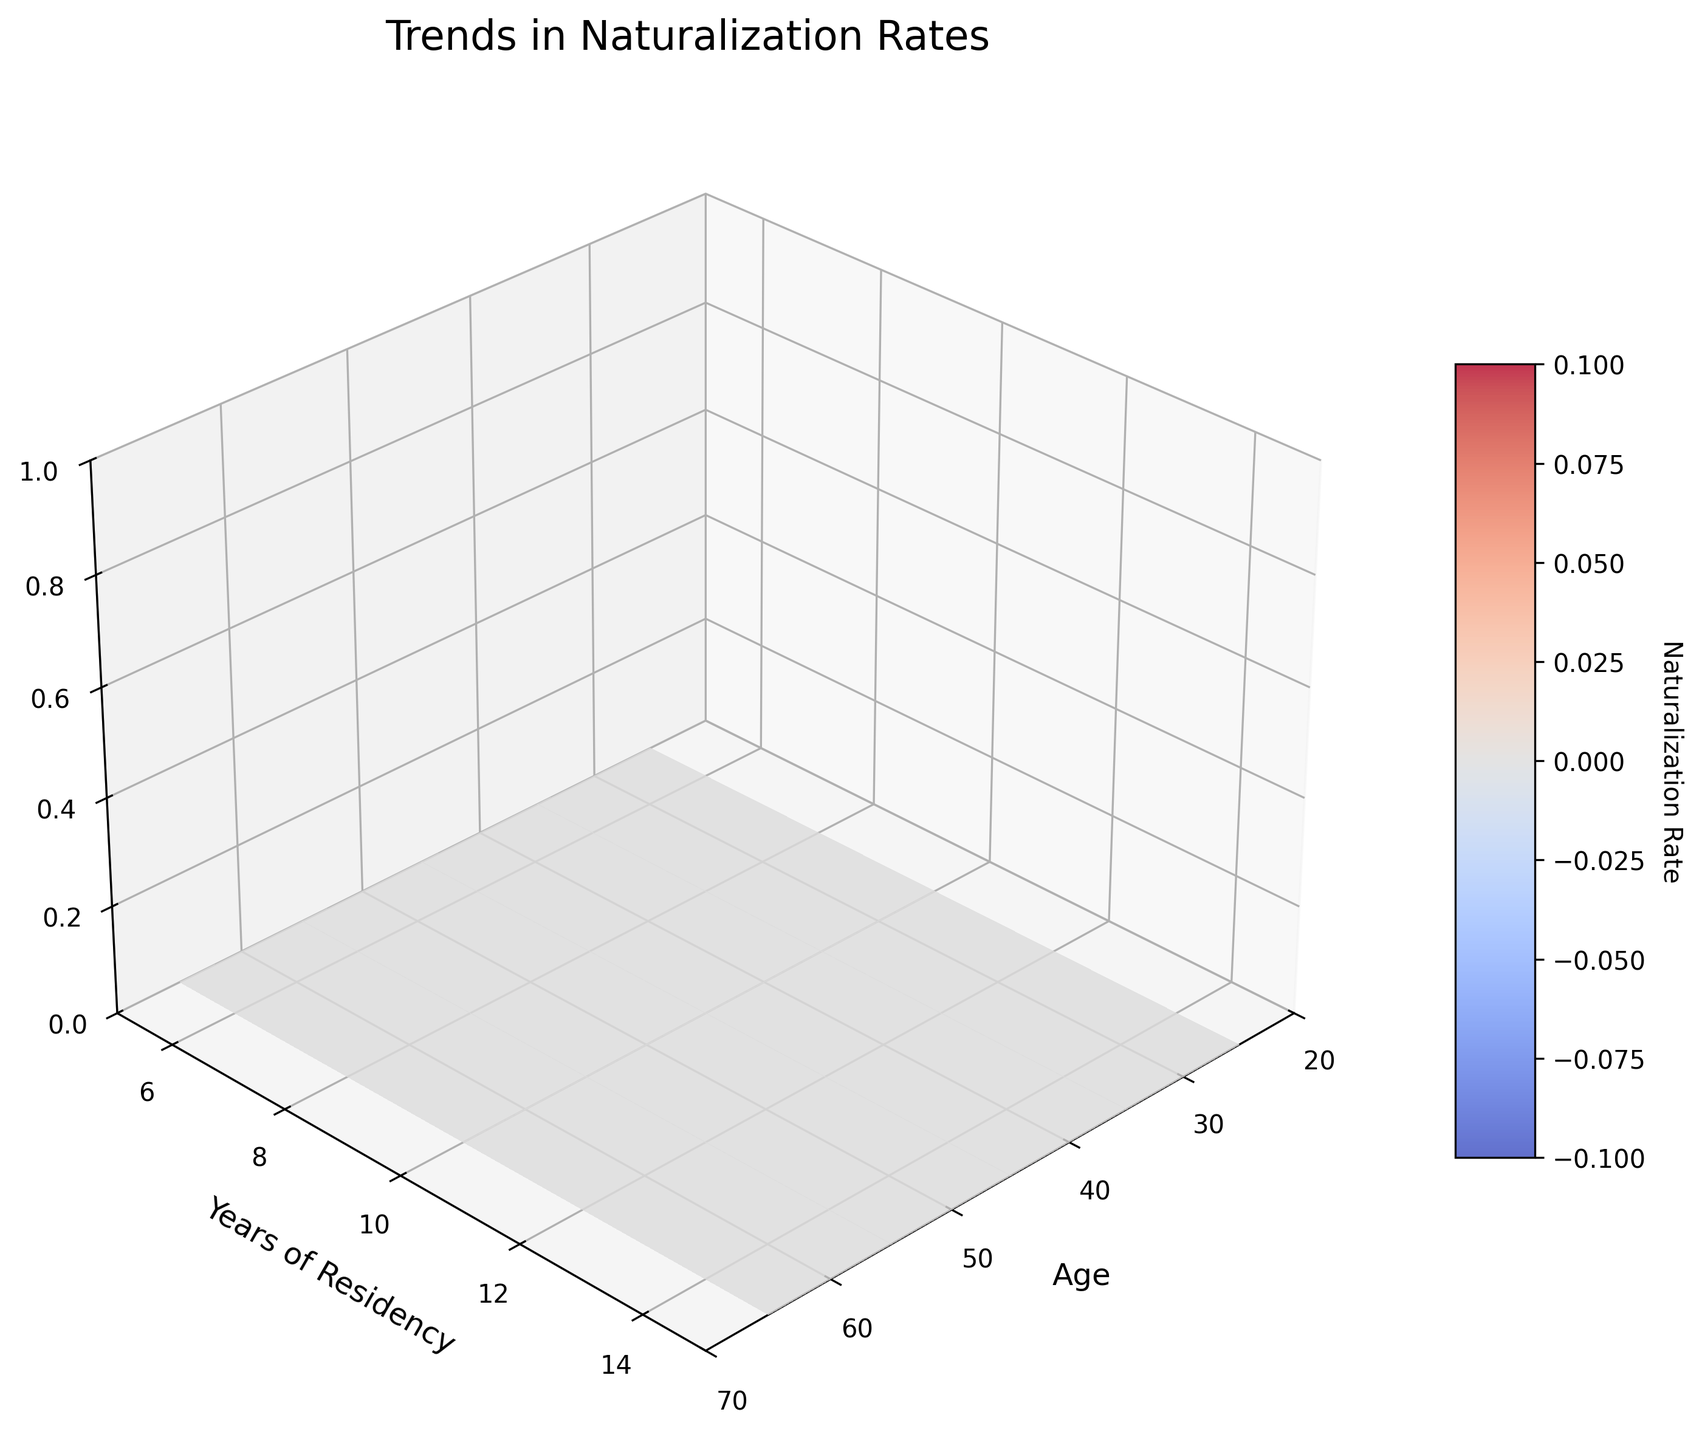What is the title of the 3D surface plot? The title is located at the top of the plot, displayed to describe the overall insight the figure represents.
Answer: Trends in Naturalization Rates What are the axis labels of the 3D surface plot? Axis labels are the text indicating what each axis represents. These are found alongside each of the figure's three axes.
Answer: Age, Years of Residency, Naturalization Rate Which age group shows the highest naturalization rate for 15 years of residency? To find this, look for the highest point on the Z-axis at the Y value representing 15 years.
Answer: 65 What is the naturalization rate for the youngest age group with the shortest residency period? Look at the Z value where Age is 25 and Years of Residency is 5.
Answer: 0.15 Compare the naturalization rates of the 35 and 45 age groups for 10 years of residency. Which is higher? Check the Z values where Age is 35 and 45 for 10 years of residency and compare them.
Answer: 45 age group How does the naturalization rate trend with increasing age for 5 years of residency? Observe the Z values along the X-axis for 5 years of residency and describe the pattern.
Answer: It increases Calculate the average naturalization rate for the 55 age group across all years of residency. Add the Z values for 55 years of age for all residency years (5, 10, 15) and divide by 3.
Answer: (0.35 + 0.65 + 0.85) / 3 ≈ 0.62 Does the naturalization rate for the 25 age group at 15 years of residency exceed that of the 45 age group at 5 years of residency? Compare the Z values for Age 25, 15 years and Age 45, 5 years.
Answer: Yes What color palette is used to represent the naturalization rate on the surface plot? The color palette represents different values using a range of colors, visible on the plot.
Answer: Coolwarm How does the naturalization rate change with years of residency within the 65 age group? Examine the Z values as Y (years of residency) increases for Age 65 and describe the trend.
Answer: It increases 